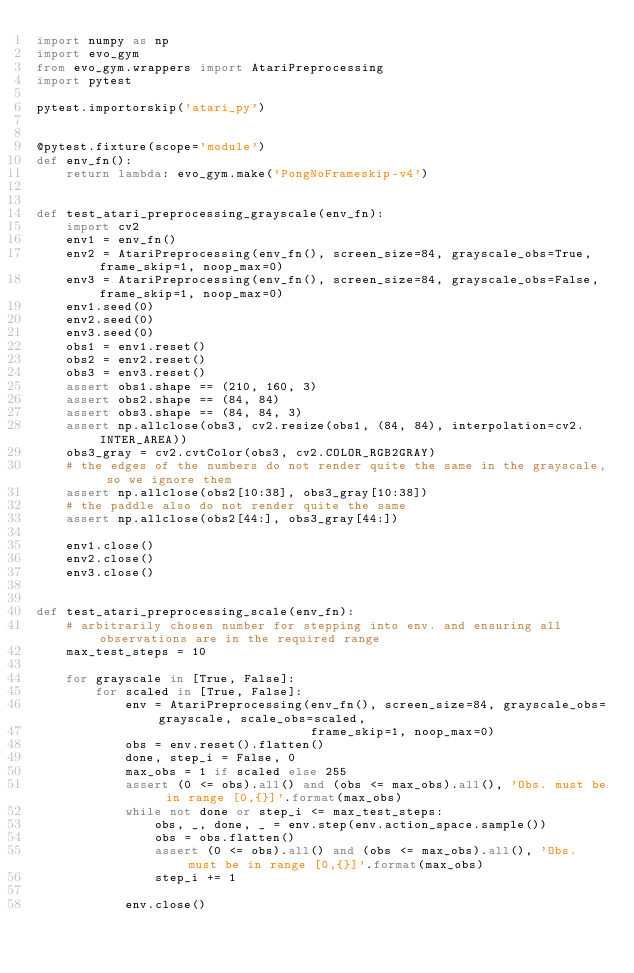<code> <loc_0><loc_0><loc_500><loc_500><_Python_>import numpy as np
import evo_gym
from evo_gym.wrappers import AtariPreprocessing
import pytest

pytest.importorskip('atari_py')


@pytest.fixture(scope='module')
def env_fn():
    return lambda: evo_gym.make('PongNoFrameskip-v4')


def test_atari_preprocessing_grayscale(env_fn):
    import cv2
    env1 = env_fn()
    env2 = AtariPreprocessing(env_fn(), screen_size=84, grayscale_obs=True, frame_skip=1, noop_max=0)
    env3 = AtariPreprocessing(env_fn(), screen_size=84, grayscale_obs=False, frame_skip=1, noop_max=0)
    env1.seed(0)
    env2.seed(0)
    env3.seed(0)
    obs1 = env1.reset()
    obs2 = env2.reset()
    obs3 = env3.reset()
    assert obs1.shape == (210, 160, 3)
    assert obs2.shape == (84, 84)
    assert obs3.shape == (84, 84, 3)
    assert np.allclose(obs3, cv2.resize(obs1, (84, 84), interpolation=cv2.INTER_AREA))
    obs3_gray = cv2.cvtColor(obs3, cv2.COLOR_RGB2GRAY)
    # the edges of the numbers do not render quite the same in the grayscale, so we ignore them
    assert np.allclose(obs2[10:38], obs3_gray[10:38])
    # the paddle also do not render quite the same
    assert np.allclose(obs2[44:], obs3_gray[44:])

    env1.close()
    env2.close()
    env3.close()


def test_atari_preprocessing_scale(env_fn):
    # arbitrarily chosen number for stepping into env. and ensuring all observations are in the required range
    max_test_steps = 10

    for grayscale in [True, False]:
        for scaled in [True, False]:
            env = AtariPreprocessing(env_fn(), screen_size=84, grayscale_obs=grayscale, scale_obs=scaled,
                                     frame_skip=1, noop_max=0)
            obs = env.reset().flatten()
            done, step_i = False, 0
            max_obs = 1 if scaled else 255
            assert (0 <= obs).all() and (obs <= max_obs).all(), 'Obs. must be in range [0,{}]'.format(max_obs)
            while not done or step_i <= max_test_steps:
                obs, _, done, _ = env.step(env.action_space.sample())
                obs = obs.flatten()
                assert (0 <= obs).all() and (obs <= max_obs).all(), 'Obs. must be in range [0,{}]'.format(max_obs)
                step_i += 1

            env.close()
</code> 